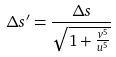<formula> <loc_0><loc_0><loc_500><loc_500>\Delta s ^ { \prime } = \frac { \Delta s } { \sqrt { 1 + \frac { v ^ { 5 } } { u ^ { 5 } } } }</formula> 